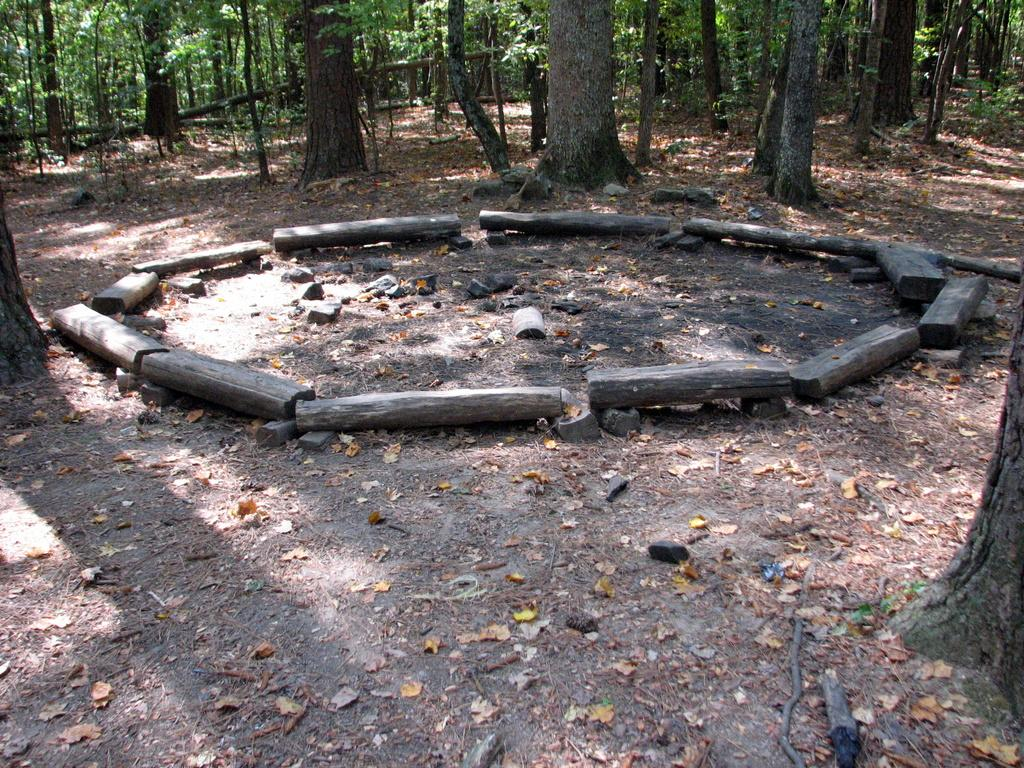What is covering the ground in the image? There are many wood pieces on the ground in the image. What can be seen in the distance behind the wood pieces? There are trees visible in the background of the image. What type of brass instrument is being played by the laborer in the image? There is no laborer or brass instrument present in the image; it only shows wood pieces on the ground and trees in the background. 